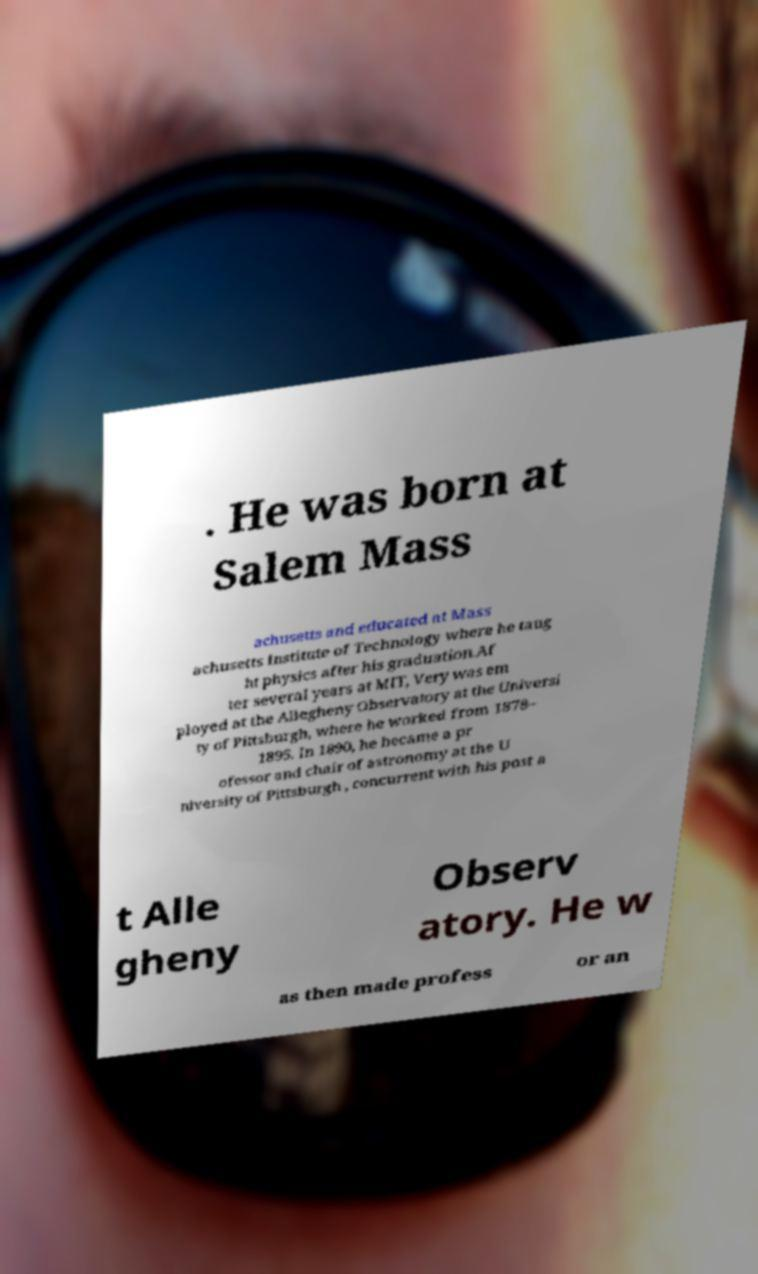What messages or text are displayed in this image? I need them in a readable, typed format. . He was born at Salem Mass achusetts and educated at Mass achusetts Institute of Technology where he taug ht physics after his graduation.Af ter several years at MIT, Very was em ployed at the Allegheny Observatory at the Universi ty of Pittsburgh, where he worked from 1878– 1895. In 1890, he became a pr ofessor and chair of astronomy at the U niversity of Pittsburgh , concurrent with his post a t Alle gheny Observ atory. He w as then made profess or an 